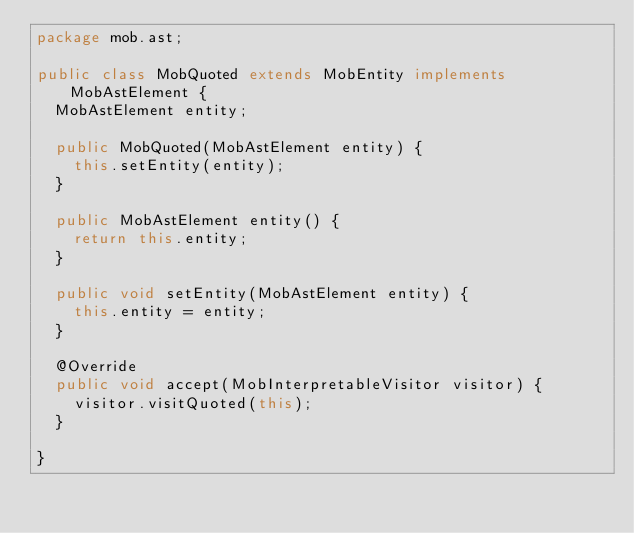Convert code to text. <code><loc_0><loc_0><loc_500><loc_500><_Java_>package mob.ast;

public class MobQuoted extends MobEntity implements MobAstElement {
	MobAstElement entity;

	public MobQuoted(MobAstElement entity) {
		this.setEntity(entity);
	}

	public MobAstElement entity() {
		return this.entity;
	}

	public void setEntity(MobAstElement entity) {
		this.entity = entity;
	}

	@Override
	public void accept(MobInterpretableVisitor visitor) {
		visitor.visitQuoted(this);
	}

}
</code> 